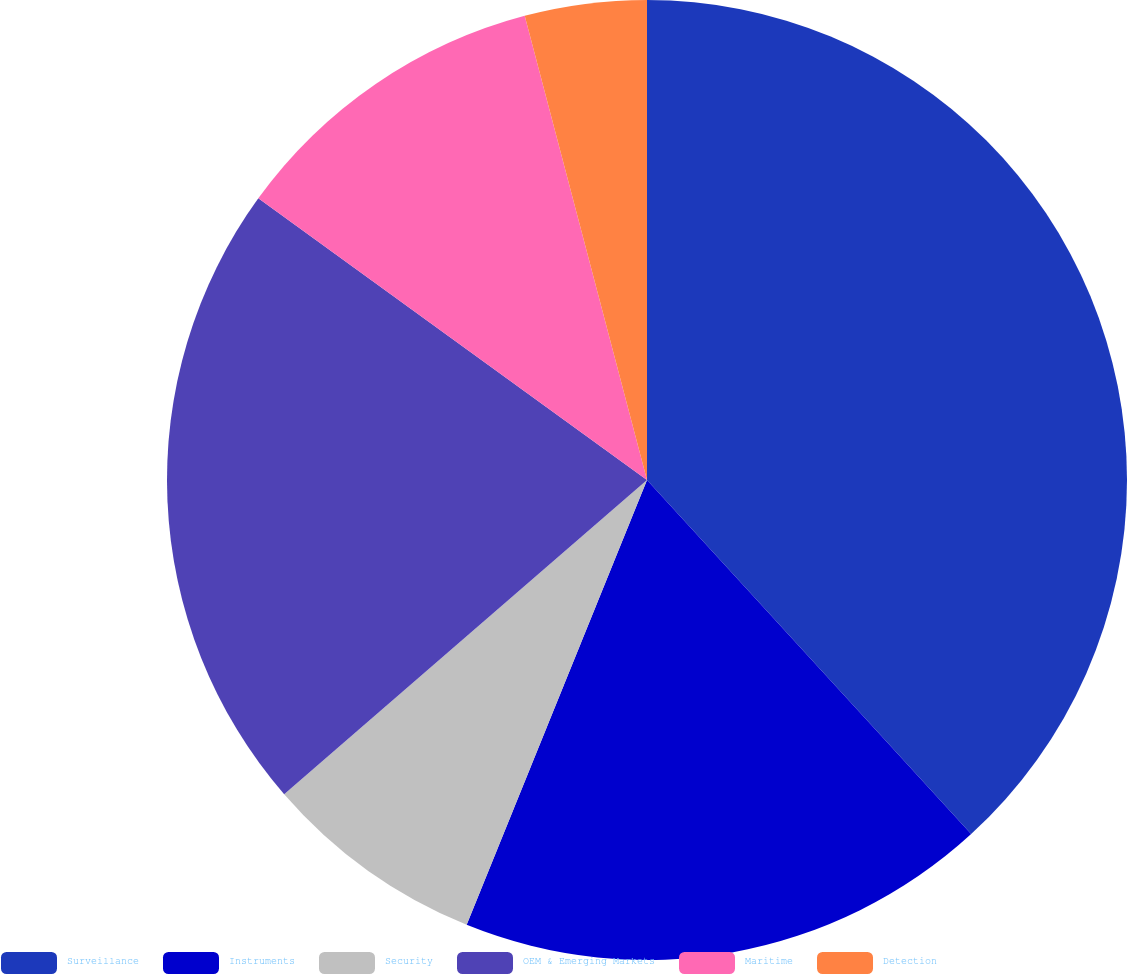Convert chart. <chart><loc_0><loc_0><loc_500><loc_500><pie_chart><fcel>Surveillance<fcel>Instruments<fcel>Security<fcel>OEM & Emerging Markets<fcel>Maritime<fcel>Detection<nl><fcel>38.2%<fcel>17.93%<fcel>7.51%<fcel>21.34%<fcel>10.92%<fcel>4.1%<nl></chart> 